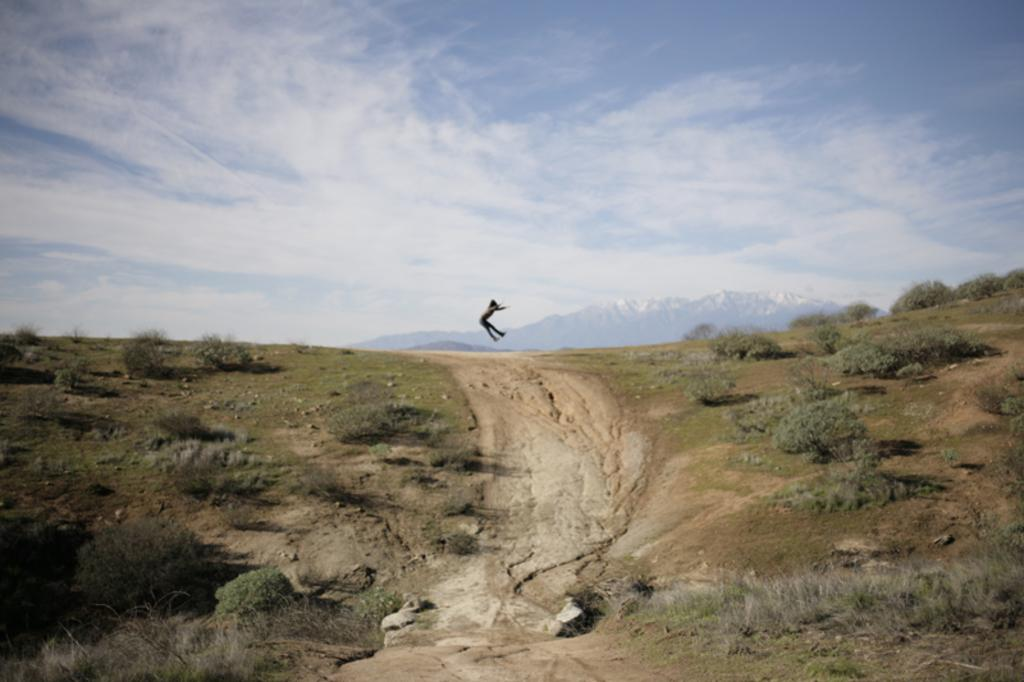Who or what is the main subject in the image? There is a person in the image. What is the person doing in the image? The person is jumping in the air. What can be seen on the ground in the image? The ground is covered with plants. What type of heart-shaped object can be seen in the person's hand while they are jumping? There is no heart-shaped object visible in the person's hand or anywhere else in the image. 